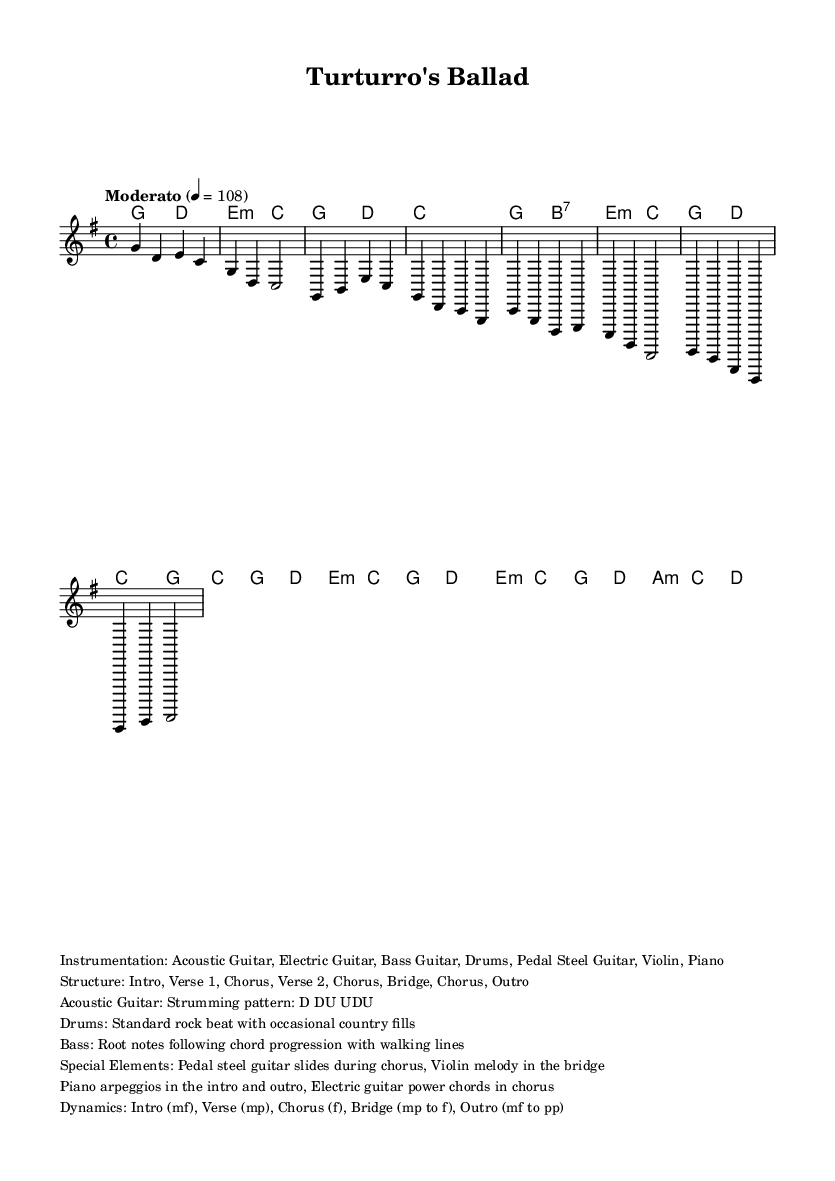What is the key signature of this music? The key signature of the piece is G major, which has one sharp (F#) indicated by the key signature at the beginning of the sheet music.
Answer: G major What is the time signature? The time signature is found at the beginning of the sheet music, showing that there are four beats in each measure, represented by 4/4.
Answer: 4/4 What is the tempo marking? The tempo marking, indicated in the sheet music, specifies that the piece should be played at a moderate speed, specifically at a quarter note equaling 108 beats per minute.
Answer: Moderato 4 = 108 How many sections are in the structure of this piece? By analyzing the structure outlined in the markup, we can see that it includes eight distinct sections: Intro, Verse 1, Chorus, Verse 2, Chorus, Bridge, Chorus, and Outro.
Answer: 8 sections What instrumentation is used in this piece? The sheet music specifies the instruments that contribute to the piece, indicating that acoustic guitar, electric guitar, bass guitar, drums, pedal steel guitar, violin, and piano are used.
Answer: Acoustic Guitar, Electric Guitar, Bass Guitar, Drums, Pedal Steel Guitar, Violin, Piano What dynamics are indicated for the Bridge section? The dynamics for the Bridge section start at mezzo-piano (mp) and move to forte (f), indicating a build in intensity during this part of the music.
Answer: mp to f What unique musical element is featured during the chorus? The sheet music indicates that pedal steel guitar slides are a special element included during the chorus, which is characteristic of the country rock fusion style.
Answer: Pedal steel guitar slides 